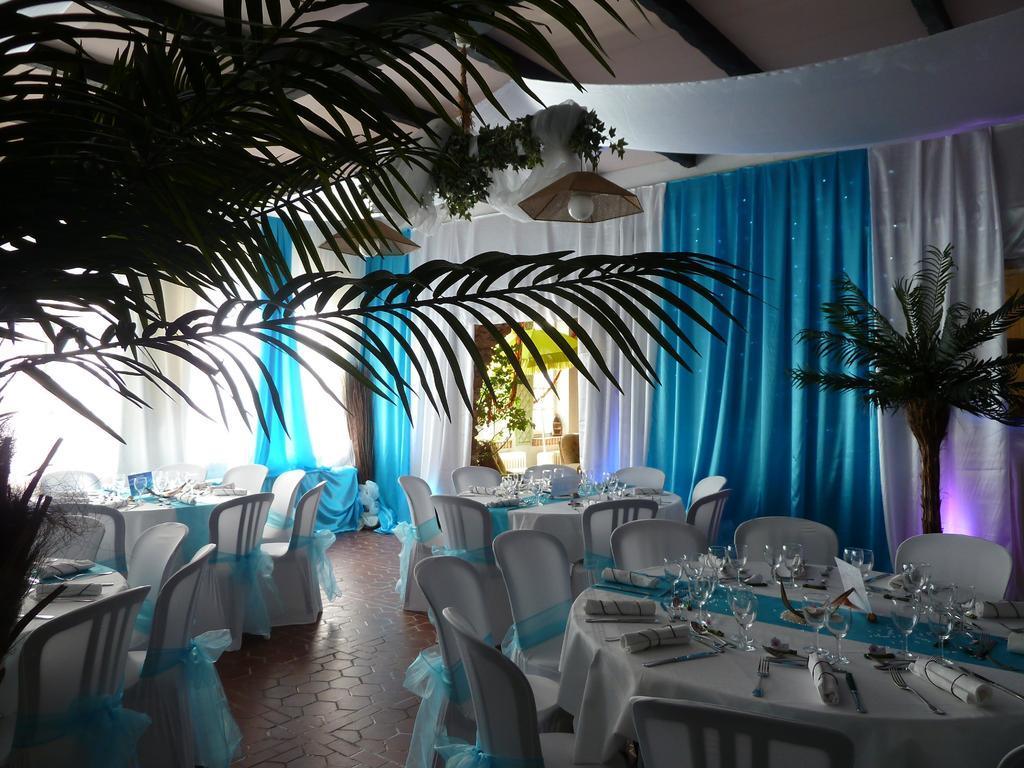In one or two sentences, can you explain what this image depicts? As we can see in the image there are plants, different colors of curtains, tables, chairs and lights. On tables there are glasses. 